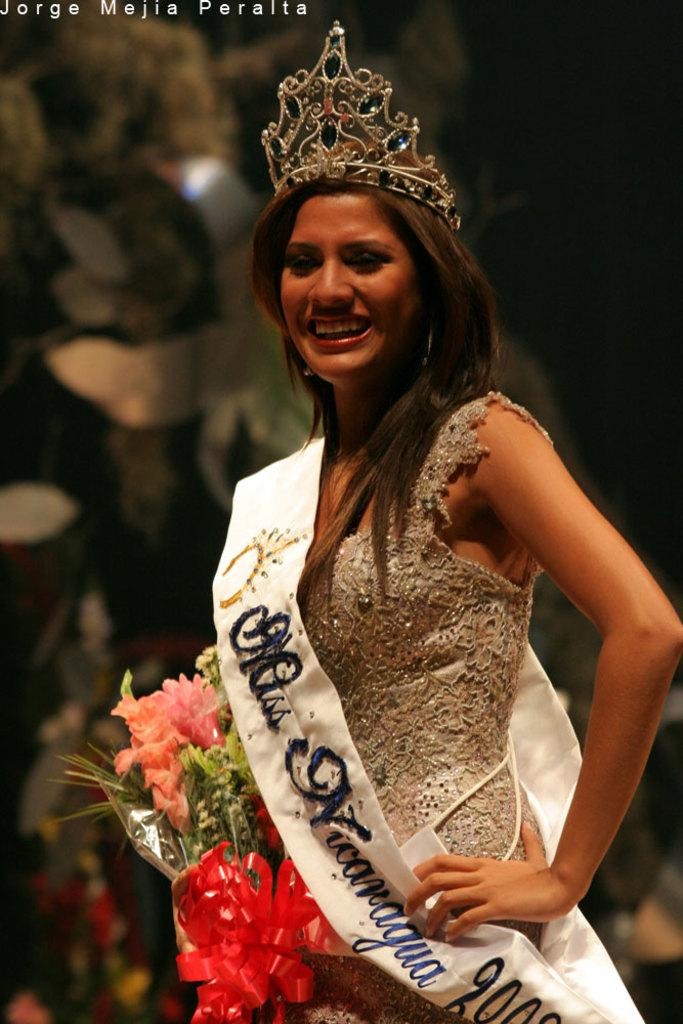Who is the main subject in the image? There is a woman in the image. What is the woman holding in the image? The woman is holding a bouquet. What is the woman's facial expression in the image? The woman is smiling in the image. What type of squirrel can be seen climbing the tree in the background of the image? There is no squirrel or tree present in the image; the background is blurred. What can be learned from the map in the image? There is no map present in the image. What can be learned from the map in the image? There is no map present in the image, so it is not possible to learn anything from it. 